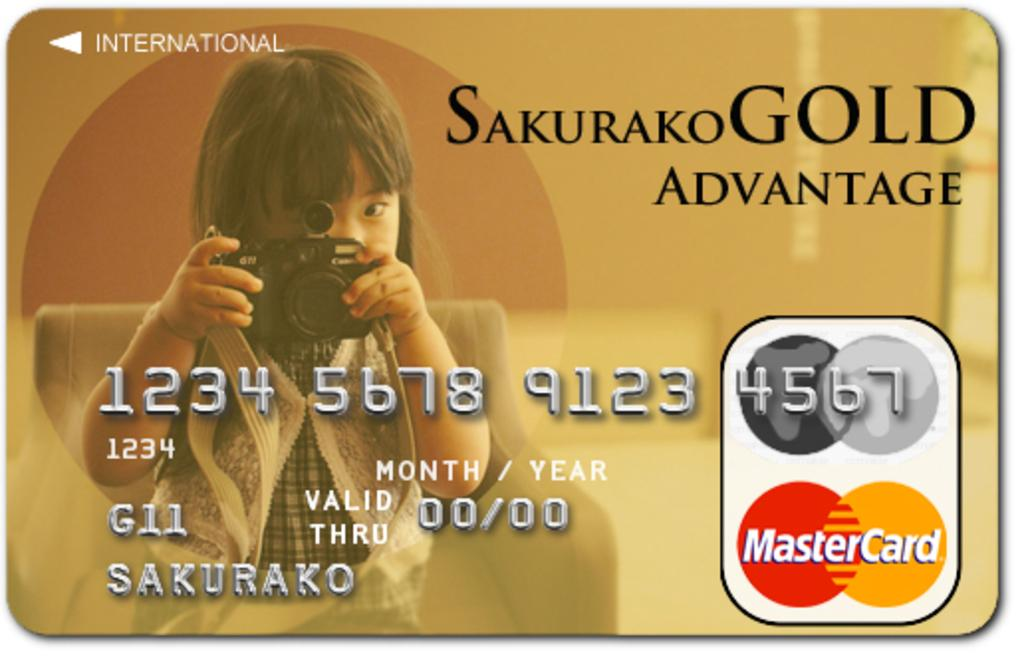What type of card is visible in the image? There is a Mastercard in the image. What is written or printed on the Mastercard? The Mastercard has some text on it. What else can be seen in the image besides the Mastercard? There is a picture of a girl in the image. What type of industry is depicted in the image? There is no depiction of an industry in the image; it features a Mastercard and a picture of a girl. Can you tell me how many wounds are visible on the girl in the image? There are no wounds visible on the girl in the image; it is a picture of a girl without any indication of injury. 